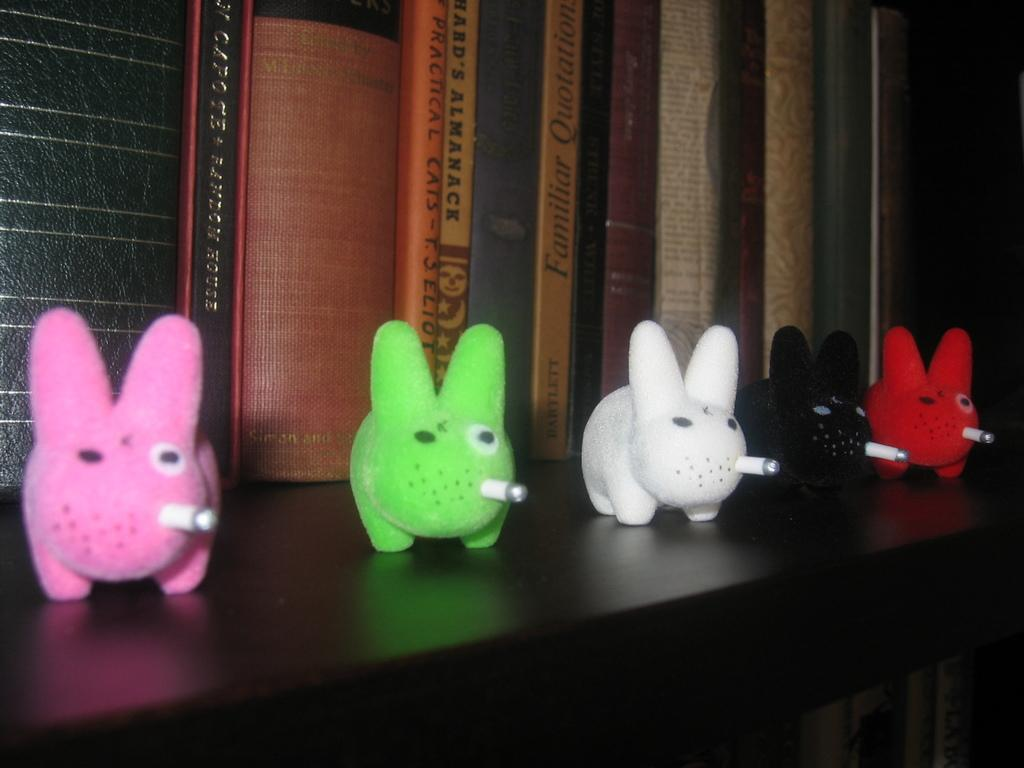What is the main object in the image? There is a table in the image. What is placed on the table? There are five toys on the table. Can you describe the toys? The toys are of different colors. What can be seen in the background of the image? There are books in the background of the image. What type of jeans are the toys wearing in the image? The toys in the image do not have any clothing, including jeans, as they are toys and not people. 